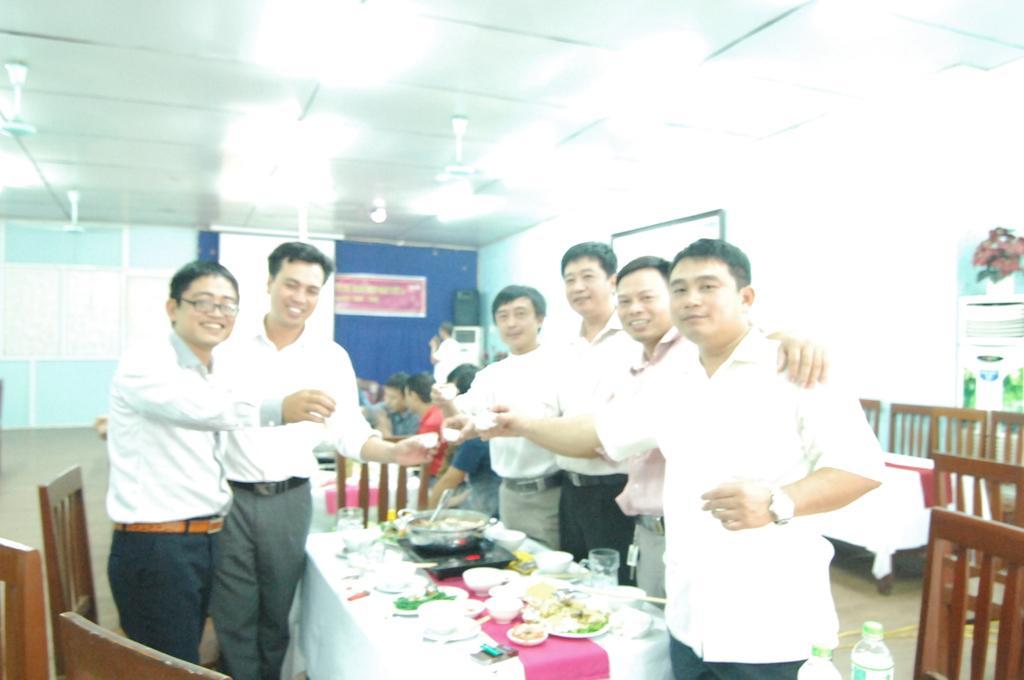Please provide a concise description of this image. In this picture I can see group of people standing, there are tables, chairs, there are bowls, plates, glasses, induction stove and some other items on the table, there are few people sitting, there are fans, banner, screen and there are pipes attached to the wall. 